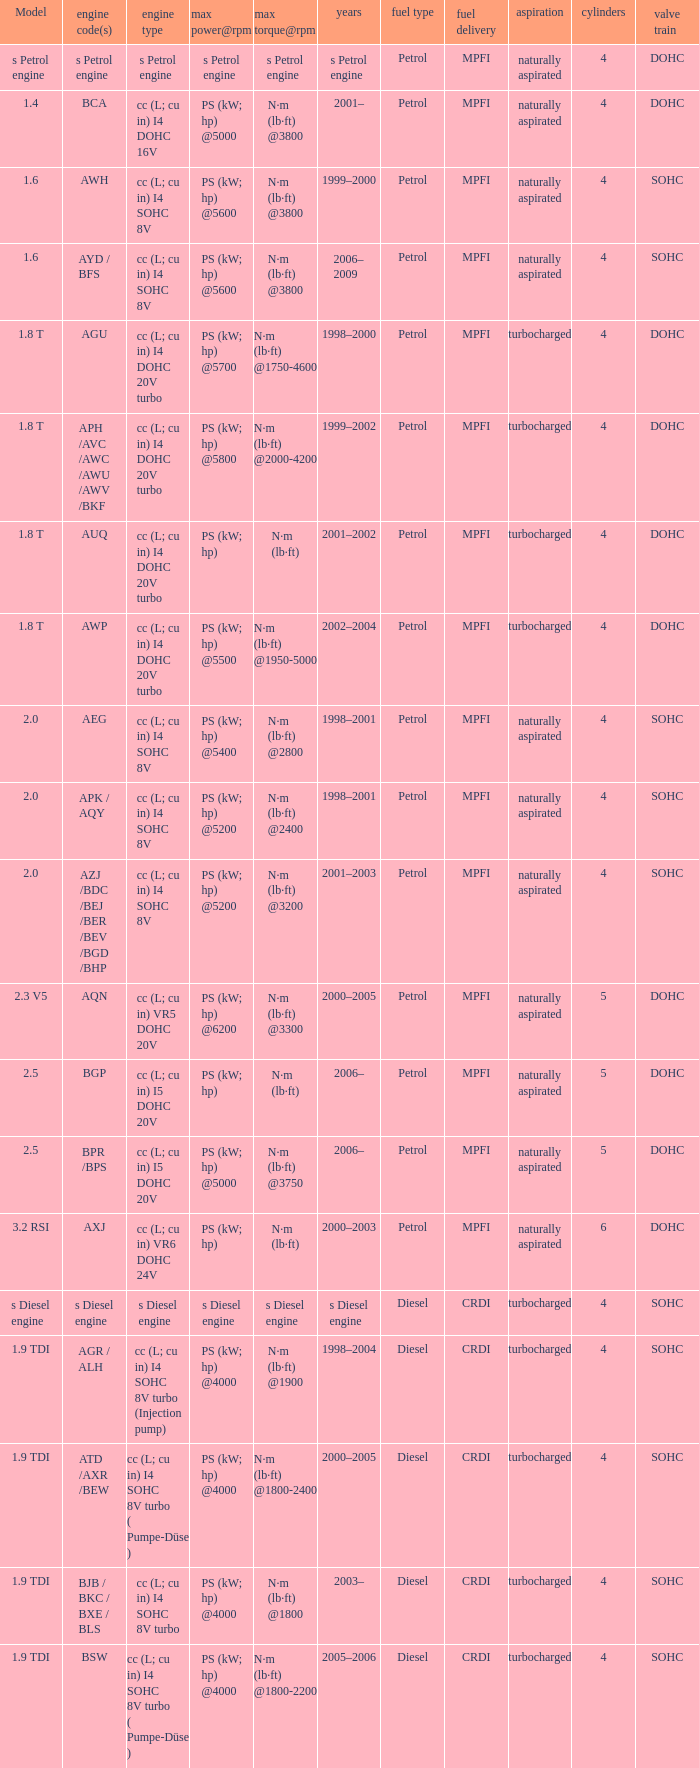What kind of engine was utilized in the model Cc (l; cu in) vr5 dohc 20v. 